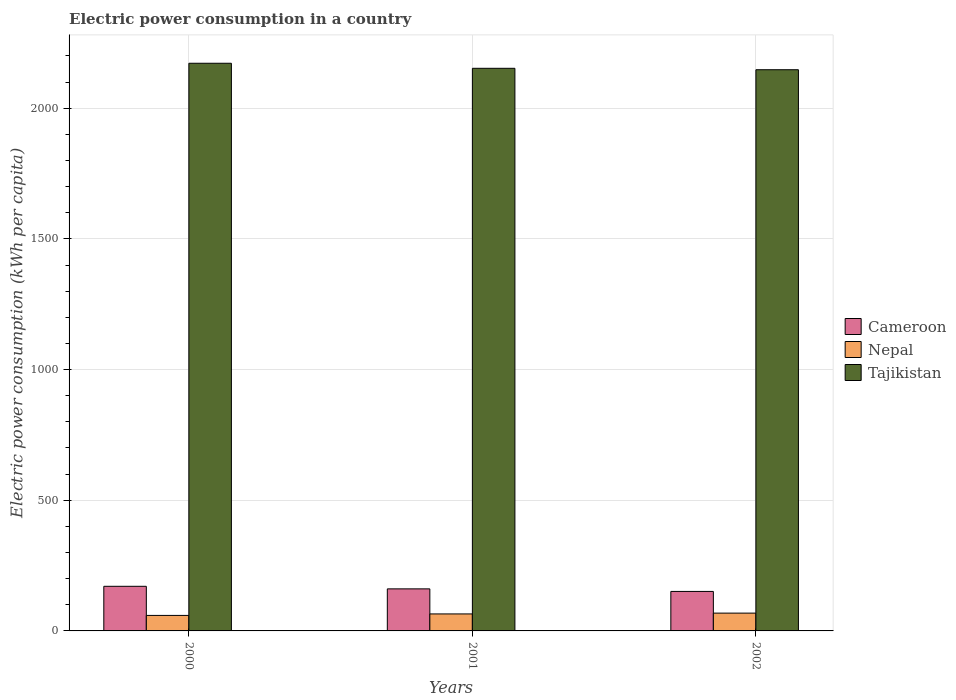Are the number of bars per tick equal to the number of legend labels?
Your response must be concise. Yes. How many bars are there on the 2nd tick from the left?
Your answer should be compact. 3. What is the label of the 1st group of bars from the left?
Provide a succinct answer. 2000. In how many cases, is the number of bars for a given year not equal to the number of legend labels?
Keep it short and to the point. 0. What is the electric power consumption in in Nepal in 2001?
Your response must be concise. 65.03. Across all years, what is the maximum electric power consumption in in Nepal?
Your response must be concise. 68.12. Across all years, what is the minimum electric power consumption in in Tajikistan?
Offer a terse response. 2147.34. In which year was the electric power consumption in in Tajikistan maximum?
Keep it short and to the point. 2000. What is the total electric power consumption in in Cameroon in the graph?
Ensure brevity in your answer.  482.77. What is the difference between the electric power consumption in in Nepal in 2000 and that in 2002?
Offer a terse response. -8.81. What is the difference between the electric power consumption in in Cameroon in 2000 and the electric power consumption in in Tajikistan in 2002?
Offer a very short reply. -1976.64. What is the average electric power consumption in in Cameroon per year?
Your answer should be compact. 160.92. In the year 2001, what is the difference between the electric power consumption in in Nepal and electric power consumption in in Tajikistan?
Keep it short and to the point. -2087.77. What is the ratio of the electric power consumption in in Nepal in 2000 to that in 2002?
Ensure brevity in your answer.  0.87. Is the electric power consumption in in Cameroon in 2000 less than that in 2002?
Offer a terse response. No. Is the difference between the electric power consumption in in Nepal in 2001 and 2002 greater than the difference between the electric power consumption in in Tajikistan in 2001 and 2002?
Offer a terse response. No. What is the difference between the highest and the second highest electric power consumption in in Cameroon?
Your answer should be very brief. 9.79. What is the difference between the highest and the lowest electric power consumption in in Tajikistan?
Ensure brevity in your answer.  24.77. Is the sum of the electric power consumption in in Nepal in 2000 and 2002 greater than the maximum electric power consumption in in Tajikistan across all years?
Make the answer very short. No. What does the 2nd bar from the left in 2002 represents?
Your answer should be compact. Nepal. What does the 1st bar from the right in 2000 represents?
Offer a terse response. Tajikistan. How many bars are there?
Offer a very short reply. 9. Are all the bars in the graph horizontal?
Offer a terse response. No. What is the difference between two consecutive major ticks on the Y-axis?
Keep it short and to the point. 500. Does the graph contain grids?
Ensure brevity in your answer.  Yes. Where does the legend appear in the graph?
Offer a very short reply. Center right. How many legend labels are there?
Provide a short and direct response. 3. What is the title of the graph?
Give a very brief answer. Electric power consumption in a country. Does "Gabon" appear as one of the legend labels in the graph?
Keep it short and to the point. No. What is the label or title of the Y-axis?
Your answer should be very brief. Electric power consumption (kWh per capita). What is the Electric power consumption (kWh per capita) in Cameroon in 2000?
Ensure brevity in your answer.  170.71. What is the Electric power consumption (kWh per capita) of Nepal in 2000?
Your response must be concise. 59.31. What is the Electric power consumption (kWh per capita) of Tajikistan in 2000?
Provide a short and direct response. 2172.11. What is the Electric power consumption (kWh per capita) in Cameroon in 2001?
Give a very brief answer. 160.92. What is the Electric power consumption (kWh per capita) of Nepal in 2001?
Your response must be concise. 65.03. What is the Electric power consumption (kWh per capita) of Tajikistan in 2001?
Give a very brief answer. 2152.8. What is the Electric power consumption (kWh per capita) in Cameroon in 2002?
Your answer should be very brief. 151.14. What is the Electric power consumption (kWh per capita) of Nepal in 2002?
Give a very brief answer. 68.12. What is the Electric power consumption (kWh per capita) of Tajikistan in 2002?
Offer a very short reply. 2147.34. Across all years, what is the maximum Electric power consumption (kWh per capita) in Cameroon?
Your answer should be very brief. 170.71. Across all years, what is the maximum Electric power consumption (kWh per capita) in Nepal?
Make the answer very short. 68.12. Across all years, what is the maximum Electric power consumption (kWh per capita) of Tajikistan?
Your response must be concise. 2172.11. Across all years, what is the minimum Electric power consumption (kWh per capita) of Cameroon?
Provide a succinct answer. 151.14. Across all years, what is the minimum Electric power consumption (kWh per capita) in Nepal?
Ensure brevity in your answer.  59.31. Across all years, what is the minimum Electric power consumption (kWh per capita) in Tajikistan?
Your response must be concise. 2147.34. What is the total Electric power consumption (kWh per capita) in Cameroon in the graph?
Provide a short and direct response. 482.77. What is the total Electric power consumption (kWh per capita) of Nepal in the graph?
Offer a very short reply. 192.46. What is the total Electric power consumption (kWh per capita) of Tajikistan in the graph?
Offer a very short reply. 6472.25. What is the difference between the Electric power consumption (kWh per capita) in Cameroon in 2000 and that in 2001?
Keep it short and to the point. 9.79. What is the difference between the Electric power consumption (kWh per capita) of Nepal in 2000 and that in 2001?
Provide a succinct answer. -5.73. What is the difference between the Electric power consumption (kWh per capita) in Tajikistan in 2000 and that in 2001?
Give a very brief answer. 19.31. What is the difference between the Electric power consumption (kWh per capita) in Cameroon in 2000 and that in 2002?
Provide a short and direct response. 19.57. What is the difference between the Electric power consumption (kWh per capita) in Nepal in 2000 and that in 2002?
Ensure brevity in your answer.  -8.81. What is the difference between the Electric power consumption (kWh per capita) of Tajikistan in 2000 and that in 2002?
Your answer should be compact. 24.77. What is the difference between the Electric power consumption (kWh per capita) in Cameroon in 2001 and that in 2002?
Your answer should be very brief. 9.79. What is the difference between the Electric power consumption (kWh per capita) of Nepal in 2001 and that in 2002?
Your answer should be compact. -3.08. What is the difference between the Electric power consumption (kWh per capita) of Tajikistan in 2001 and that in 2002?
Offer a very short reply. 5.46. What is the difference between the Electric power consumption (kWh per capita) in Cameroon in 2000 and the Electric power consumption (kWh per capita) in Nepal in 2001?
Provide a short and direct response. 105.67. What is the difference between the Electric power consumption (kWh per capita) in Cameroon in 2000 and the Electric power consumption (kWh per capita) in Tajikistan in 2001?
Your response must be concise. -1982.09. What is the difference between the Electric power consumption (kWh per capita) in Nepal in 2000 and the Electric power consumption (kWh per capita) in Tajikistan in 2001?
Your response must be concise. -2093.49. What is the difference between the Electric power consumption (kWh per capita) of Cameroon in 2000 and the Electric power consumption (kWh per capita) of Nepal in 2002?
Ensure brevity in your answer.  102.59. What is the difference between the Electric power consumption (kWh per capita) in Cameroon in 2000 and the Electric power consumption (kWh per capita) in Tajikistan in 2002?
Give a very brief answer. -1976.64. What is the difference between the Electric power consumption (kWh per capita) in Nepal in 2000 and the Electric power consumption (kWh per capita) in Tajikistan in 2002?
Offer a terse response. -2088.04. What is the difference between the Electric power consumption (kWh per capita) in Cameroon in 2001 and the Electric power consumption (kWh per capita) in Nepal in 2002?
Your answer should be very brief. 92.81. What is the difference between the Electric power consumption (kWh per capita) of Cameroon in 2001 and the Electric power consumption (kWh per capita) of Tajikistan in 2002?
Your answer should be very brief. -1986.42. What is the difference between the Electric power consumption (kWh per capita) in Nepal in 2001 and the Electric power consumption (kWh per capita) in Tajikistan in 2002?
Ensure brevity in your answer.  -2082.31. What is the average Electric power consumption (kWh per capita) of Cameroon per year?
Give a very brief answer. 160.92. What is the average Electric power consumption (kWh per capita) in Nepal per year?
Provide a succinct answer. 64.15. What is the average Electric power consumption (kWh per capita) of Tajikistan per year?
Give a very brief answer. 2157.42. In the year 2000, what is the difference between the Electric power consumption (kWh per capita) of Cameroon and Electric power consumption (kWh per capita) of Nepal?
Provide a succinct answer. 111.4. In the year 2000, what is the difference between the Electric power consumption (kWh per capita) of Cameroon and Electric power consumption (kWh per capita) of Tajikistan?
Make the answer very short. -2001.4. In the year 2000, what is the difference between the Electric power consumption (kWh per capita) in Nepal and Electric power consumption (kWh per capita) in Tajikistan?
Make the answer very short. -2112.8. In the year 2001, what is the difference between the Electric power consumption (kWh per capita) of Cameroon and Electric power consumption (kWh per capita) of Nepal?
Provide a succinct answer. 95.89. In the year 2001, what is the difference between the Electric power consumption (kWh per capita) in Cameroon and Electric power consumption (kWh per capita) in Tajikistan?
Ensure brevity in your answer.  -1991.88. In the year 2001, what is the difference between the Electric power consumption (kWh per capita) of Nepal and Electric power consumption (kWh per capita) of Tajikistan?
Keep it short and to the point. -2087.77. In the year 2002, what is the difference between the Electric power consumption (kWh per capita) of Cameroon and Electric power consumption (kWh per capita) of Nepal?
Provide a succinct answer. 83.02. In the year 2002, what is the difference between the Electric power consumption (kWh per capita) of Cameroon and Electric power consumption (kWh per capita) of Tajikistan?
Provide a succinct answer. -1996.21. In the year 2002, what is the difference between the Electric power consumption (kWh per capita) of Nepal and Electric power consumption (kWh per capita) of Tajikistan?
Your response must be concise. -2079.23. What is the ratio of the Electric power consumption (kWh per capita) of Cameroon in 2000 to that in 2001?
Ensure brevity in your answer.  1.06. What is the ratio of the Electric power consumption (kWh per capita) of Nepal in 2000 to that in 2001?
Offer a terse response. 0.91. What is the ratio of the Electric power consumption (kWh per capita) of Tajikistan in 2000 to that in 2001?
Provide a succinct answer. 1.01. What is the ratio of the Electric power consumption (kWh per capita) in Cameroon in 2000 to that in 2002?
Offer a very short reply. 1.13. What is the ratio of the Electric power consumption (kWh per capita) in Nepal in 2000 to that in 2002?
Ensure brevity in your answer.  0.87. What is the ratio of the Electric power consumption (kWh per capita) in Tajikistan in 2000 to that in 2002?
Provide a succinct answer. 1.01. What is the ratio of the Electric power consumption (kWh per capita) of Cameroon in 2001 to that in 2002?
Offer a very short reply. 1.06. What is the ratio of the Electric power consumption (kWh per capita) in Nepal in 2001 to that in 2002?
Offer a very short reply. 0.95. What is the ratio of the Electric power consumption (kWh per capita) of Tajikistan in 2001 to that in 2002?
Give a very brief answer. 1. What is the difference between the highest and the second highest Electric power consumption (kWh per capita) of Cameroon?
Provide a short and direct response. 9.79. What is the difference between the highest and the second highest Electric power consumption (kWh per capita) of Nepal?
Make the answer very short. 3.08. What is the difference between the highest and the second highest Electric power consumption (kWh per capita) in Tajikistan?
Give a very brief answer. 19.31. What is the difference between the highest and the lowest Electric power consumption (kWh per capita) in Cameroon?
Make the answer very short. 19.57. What is the difference between the highest and the lowest Electric power consumption (kWh per capita) in Nepal?
Make the answer very short. 8.81. What is the difference between the highest and the lowest Electric power consumption (kWh per capita) of Tajikistan?
Offer a very short reply. 24.77. 